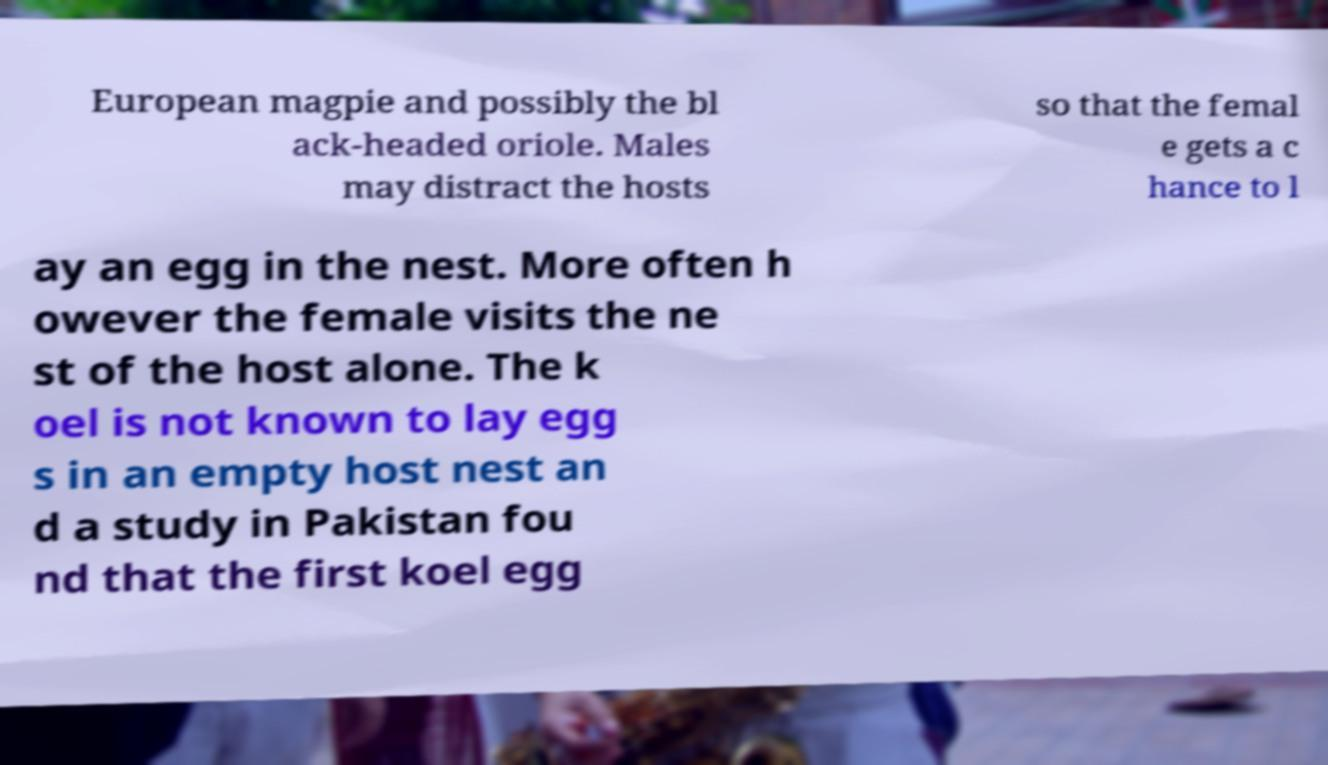Could you extract and type out the text from this image? European magpie and possibly the bl ack-headed oriole. Males may distract the hosts so that the femal e gets a c hance to l ay an egg in the nest. More often h owever the female visits the ne st of the host alone. The k oel is not known to lay egg s in an empty host nest an d a study in Pakistan fou nd that the first koel egg 